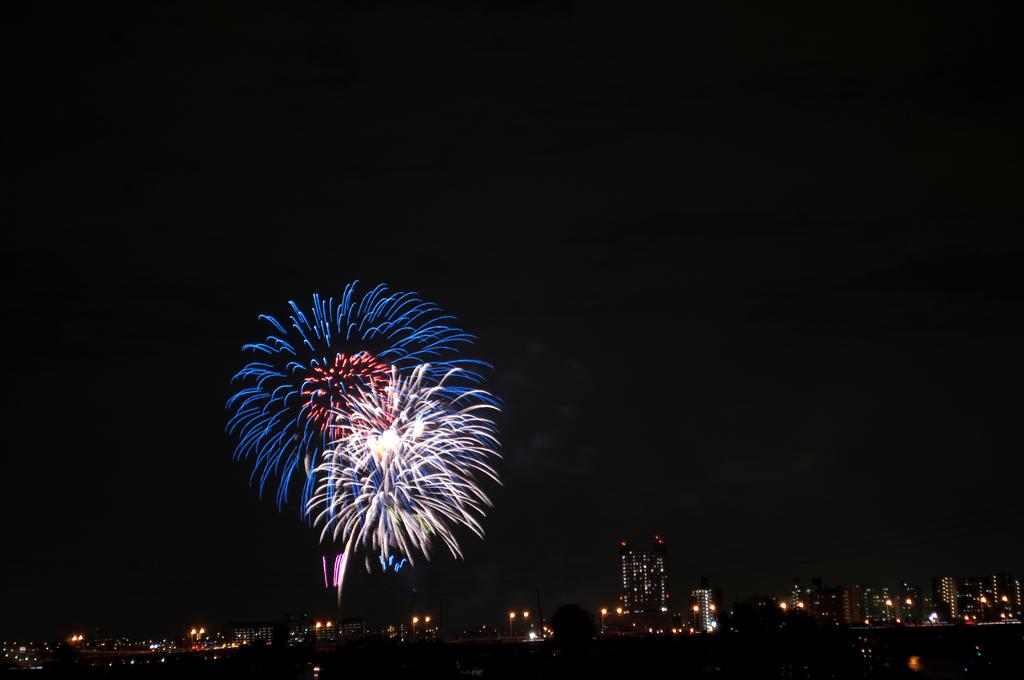What time of day was the image taken? The image was taken at night. What can be seen in the image besides the night sky? There are multiple buildings in the image. How are the buildings illuminated in the image? The buildings have lights. What can be observed at the top of the image? There are sparkles of different colors at the top of the image. What type of pencil is being used to draw the record in the image? There is no pencil or record present in the image. 